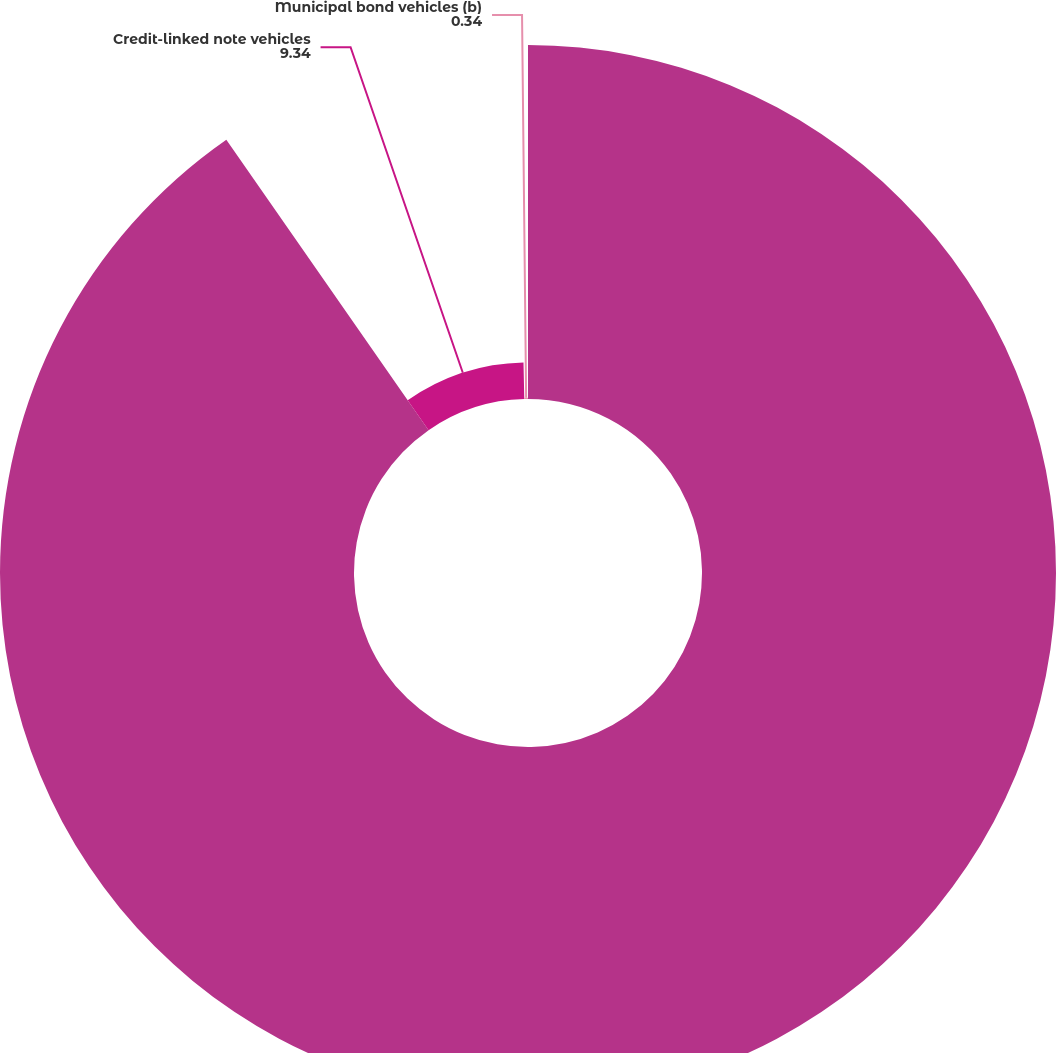Convert chart to OTSL. <chart><loc_0><loc_0><loc_500><loc_500><pie_chart><fcel>December 31 (in billions)<fcel>Credit-linked note vehicles<fcel>Municipal bond vehicles (b)<nl><fcel>90.33%<fcel>9.34%<fcel>0.34%<nl></chart> 